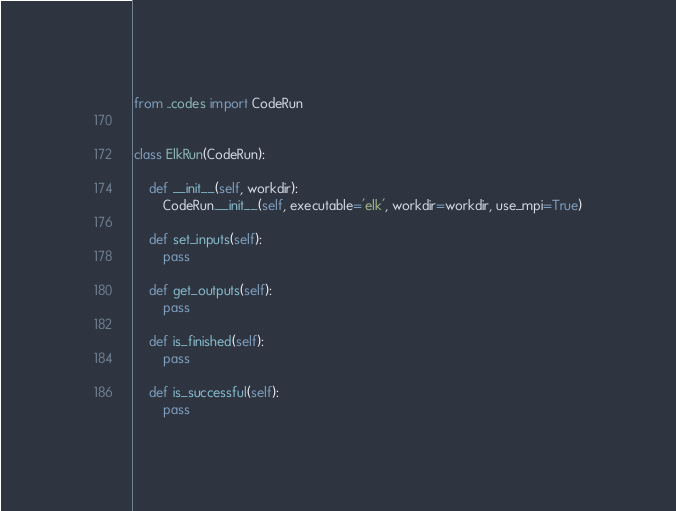Convert code to text. <code><loc_0><loc_0><loc_500><loc_500><_Python_>from ..codes import CodeRun


class ElkRun(CodeRun):

    def __init__(self, workdir):
        CodeRun.__init__(self, executable='elk', workdir=workdir, use_mpi=True)

    def set_inputs(self):
        pass

    def get_outputs(self):
        pass

    def is_finished(self):
        pass

    def is_successful(self):
        pass
</code> 